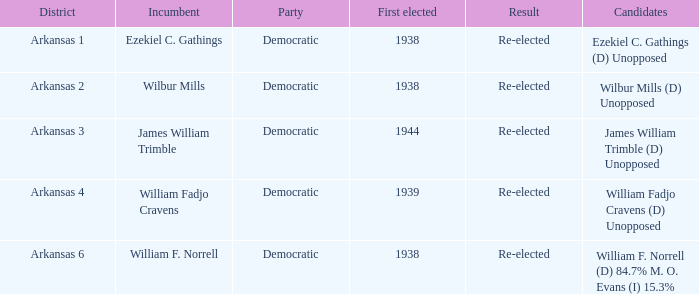How many were first elected in the Arkansas 4 district? 1.0. Can you give me this table as a dict? {'header': ['District', 'Incumbent', 'Party', 'First elected', 'Result', 'Candidates'], 'rows': [['Arkansas 1', 'Ezekiel C. Gathings', 'Democratic', '1938', 'Re-elected', 'Ezekiel C. Gathings (D) Unopposed'], ['Arkansas 2', 'Wilbur Mills', 'Democratic', '1938', 'Re-elected', 'Wilbur Mills (D) Unopposed'], ['Arkansas 3', 'James William Trimble', 'Democratic', '1944', 'Re-elected', 'James William Trimble (D) Unopposed'], ['Arkansas 4', 'William Fadjo Cravens', 'Democratic', '1939', 'Re-elected', 'William Fadjo Cravens (D) Unopposed'], ['Arkansas 6', 'William F. Norrell', 'Democratic', '1938', 'Re-elected', 'William F. Norrell (D) 84.7% M. O. Evans (I) 15.3%']]} 